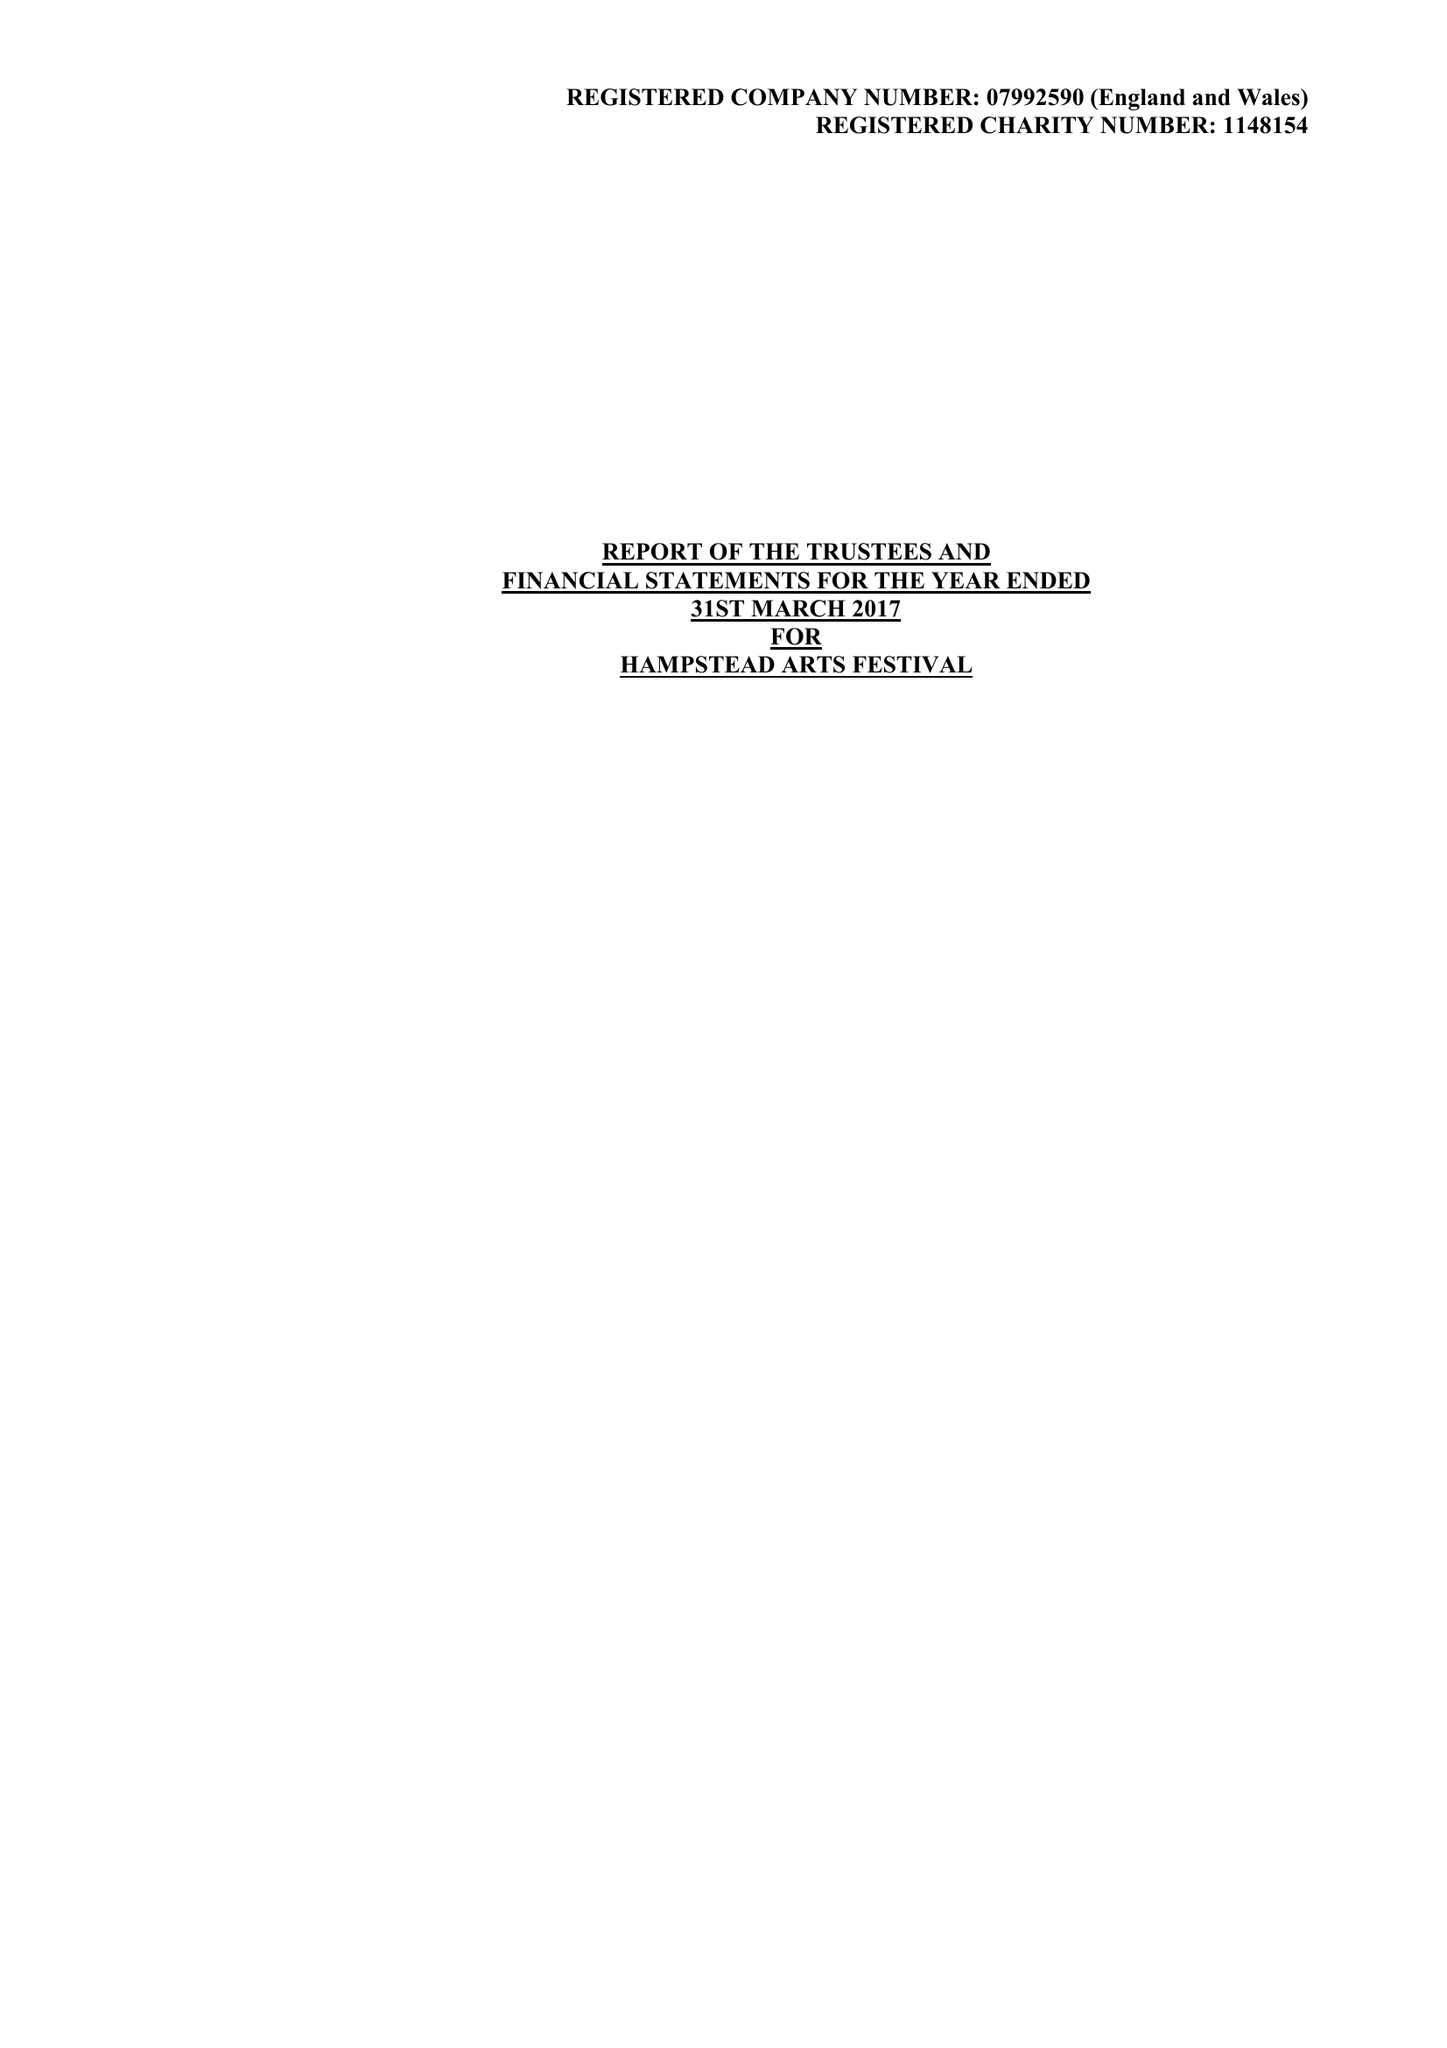What is the value for the address__street_line?
Answer the question using a single word or phrase. 31/33 COLLEGE ROAD 